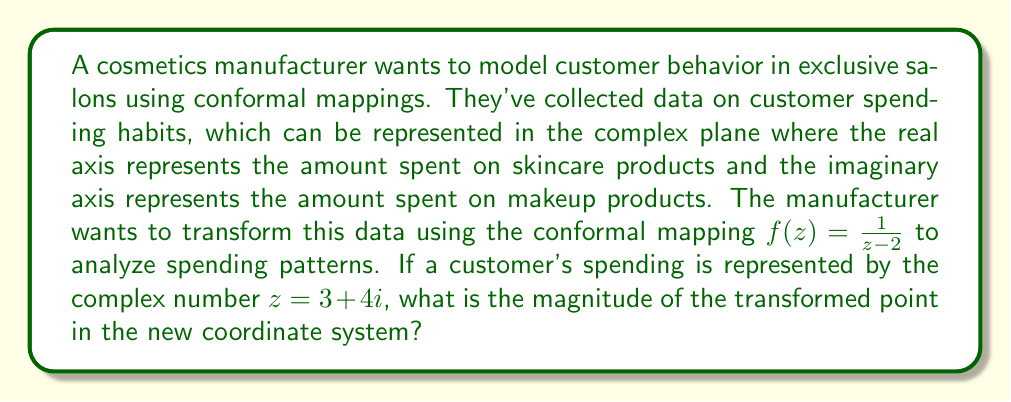Help me with this question. To solve this problem, we'll follow these steps:

1) We're given the conformal mapping $f(z) = \frac{1}{z-2}$ and the customer's spending represented by $z = 3 + 4i$.

2) First, let's calculate $z - 2$:
   $z - 2 = (3 + 4i) - 2 = 1 + 4i$

3) Now, we need to find $\frac{1}{1+4i}$. To do this, we'll multiply both numerator and denominator by the complex conjugate of the denominator:

   $$\frac{1}{1+4i} \cdot \frac{1-4i}{1-4i} = \frac{1-4i}{(1+4i)(1-4i)} = \frac{1-4i}{1+16} = \frac{1-4i}{17}$$

4) This gives us the transformed point:

   $$f(z) = \frac{1-4i}{17} = \frac{1}{17} - \frac{4i}{17}$$

5) To find the magnitude of this point, we use the formula $|a+bi| = \sqrt{a^2 + b^2}$:

   $$\left|\frac{1}{17} - \frac{4i}{17}\right| = \sqrt{\left(\frac{1}{17}\right)^2 + \left(\frac{4}{17}\right)^2}$$

6) Simplifying under the square root:

   $$\sqrt{\frac{1}{289} + \frac{16}{289}} = \sqrt{\frac{17}{289}} = \frac{\sqrt{17}}{17}$$

Therefore, the magnitude of the transformed point is $\frac{\sqrt{17}}{17}$.
Answer: $\frac{\sqrt{17}}{17}$ 